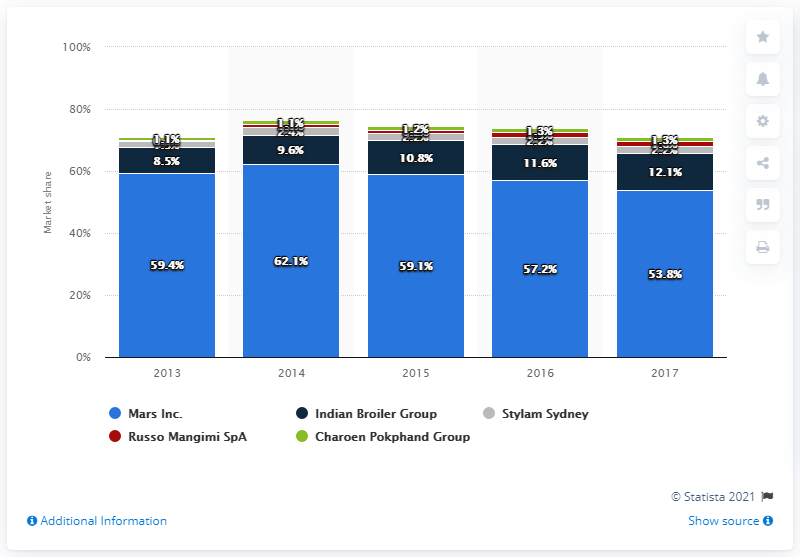Draw attention to some important aspects in this diagram. In 2017, Mars held a market share of 53.8% in India. The most popular company selling pet food in India in 2017 was Mars Inc. The Compounded Annual Growth Rate (CAGR) of Pedigree between 2013 and 2017 was 53.8%. 